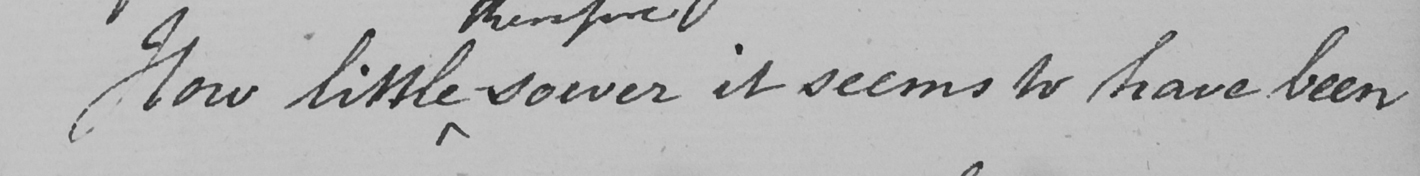What is written in this line of handwriting? How little soever it seems to have been 